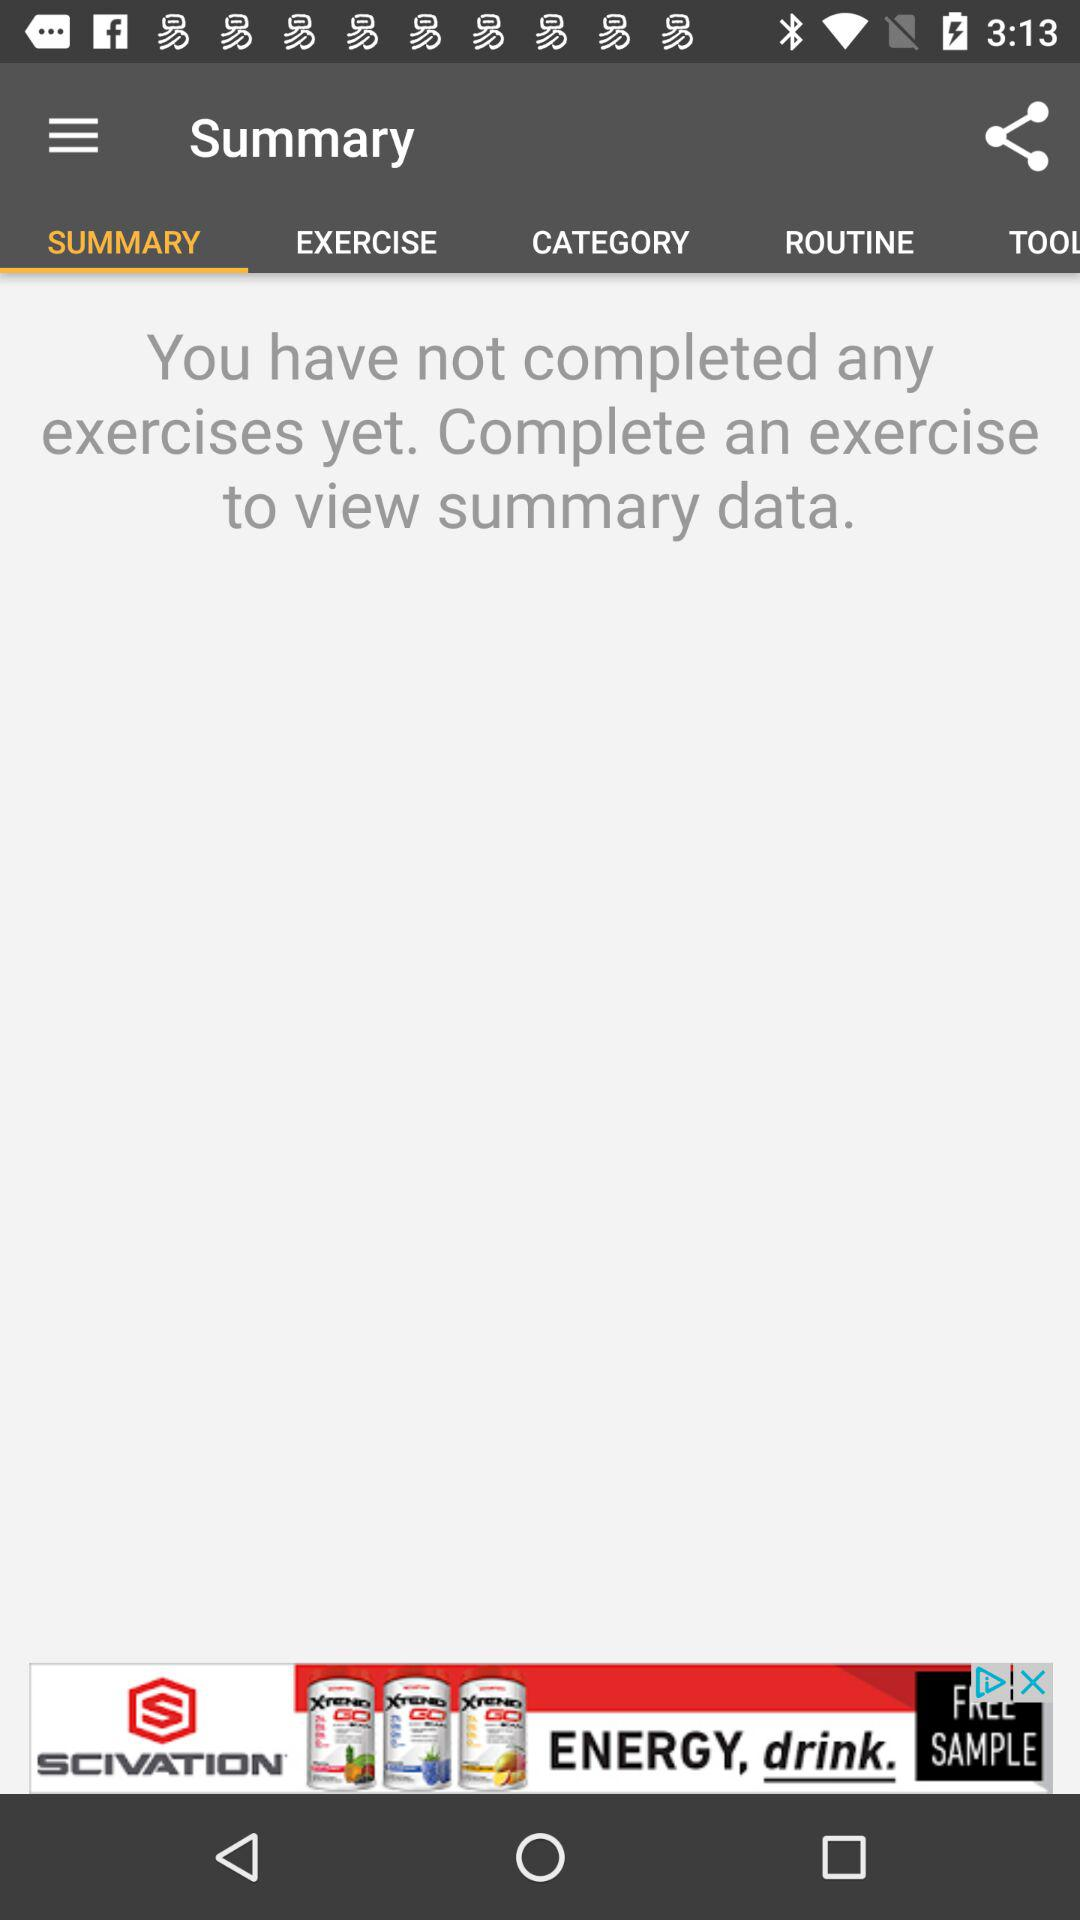Which tab is selected? The selected tab is "SUMMARY". 